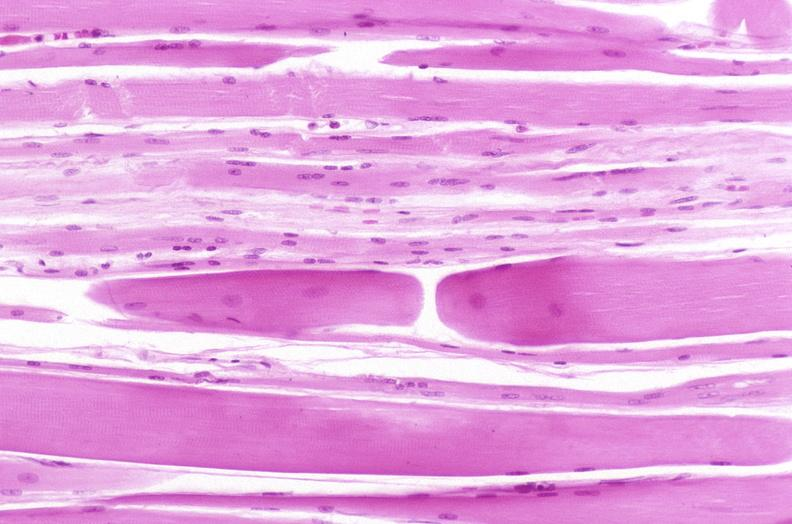s musculoskeletal present?
Answer the question using a single word or phrase. Yes 